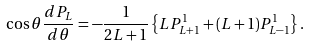<formula> <loc_0><loc_0><loc_500><loc_500>\cos \theta \frac { d P _ { L } } { d \theta } = - \frac { 1 } { 2 L + 1 } \left \{ L P ^ { 1 } _ { L + 1 } + ( L + 1 ) P ^ { 1 } _ { L - 1 } \right \} .</formula> 